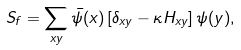Convert formula to latex. <formula><loc_0><loc_0><loc_500><loc_500>S _ { f } = \sum _ { x y } \bar { \psi } ( x ) \left [ \delta _ { x y } - \kappa H _ { x y } \right ] \psi ( y ) ,</formula> 